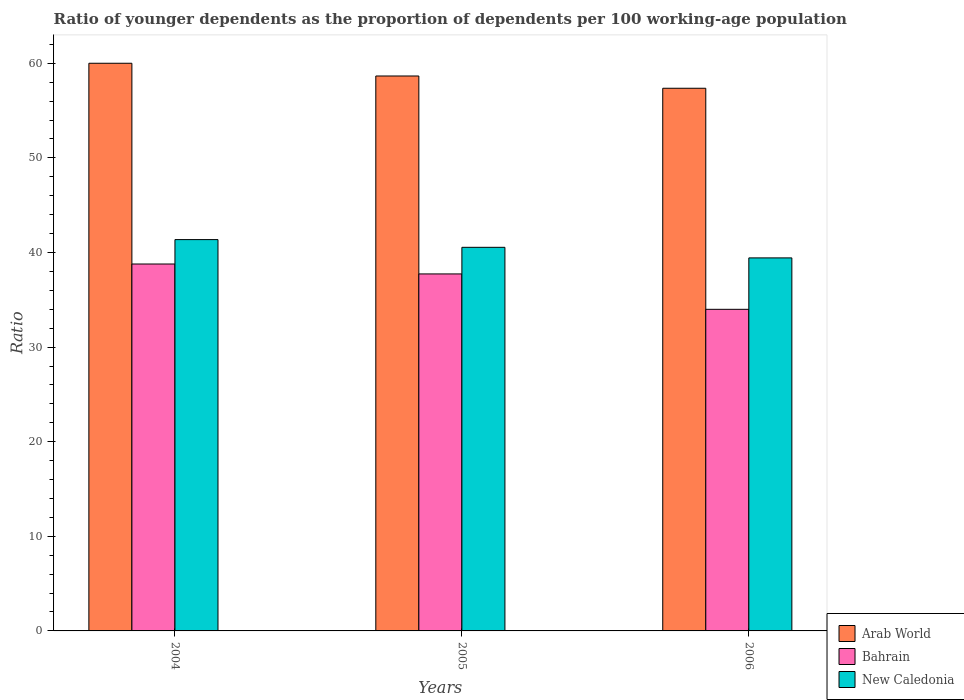How many groups of bars are there?
Offer a terse response. 3. What is the age dependency ratio(young) in New Caledonia in 2005?
Your response must be concise. 40.55. Across all years, what is the maximum age dependency ratio(young) in Arab World?
Your answer should be compact. 60. Across all years, what is the minimum age dependency ratio(young) in Bahrain?
Your answer should be very brief. 33.99. What is the total age dependency ratio(young) in New Caledonia in the graph?
Ensure brevity in your answer.  121.34. What is the difference between the age dependency ratio(young) in New Caledonia in 2004 and that in 2005?
Offer a terse response. 0.82. What is the difference between the age dependency ratio(young) in New Caledonia in 2006 and the age dependency ratio(young) in Bahrain in 2004?
Your response must be concise. 0.65. What is the average age dependency ratio(young) in New Caledonia per year?
Your answer should be very brief. 40.45. In the year 2004, what is the difference between the age dependency ratio(young) in Arab World and age dependency ratio(young) in Bahrain?
Your answer should be very brief. 21.22. What is the ratio of the age dependency ratio(young) in New Caledonia in 2005 to that in 2006?
Your response must be concise. 1.03. Is the age dependency ratio(young) in Bahrain in 2004 less than that in 2006?
Your response must be concise. No. What is the difference between the highest and the second highest age dependency ratio(young) in Bahrain?
Provide a short and direct response. 1.05. What is the difference between the highest and the lowest age dependency ratio(young) in New Caledonia?
Provide a short and direct response. 1.93. In how many years, is the age dependency ratio(young) in Arab World greater than the average age dependency ratio(young) in Arab World taken over all years?
Offer a terse response. 1. Is the sum of the age dependency ratio(young) in New Caledonia in 2004 and 2005 greater than the maximum age dependency ratio(young) in Arab World across all years?
Your answer should be very brief. Yes. What does the 1st bar from the left in 2004 represents?
Give a very brief answer. Arab World. What does the 2nd bar from the right in 2004 represents?
Provide a short and direct response. Bahrain. Is it the case that in every year, the sum of the age dependency ratio(young) in Arab World and age dependency ratio(young) in New Caledonia is greater than the age dependency ratio(young) in Bahrain?
Your response must be concise. Yes. How many bars are there?
Your response must be concise. 9. Are all the bars in the graph horizontal?
Provide a succinct answer. No. Does the graph contain any zero values?
Offer a very short reply. No. How many legend labels are there?
Make the answer very short. 3. What is the title of the graph?
Offer a very short reply. Ratio of younger dependents as the proportion of dependents per 100 working-age population. What is the label or title of the Y-axis?
Your response must be concise. Ratio. What is the Ratio of Arab World in 2004?
Make the answer very short. 60. What is the Ratio of Bahrain in 2004?
Provide a short and direct response. 38.78. What is the Ratio in New Caledonia in 2004?
Offer a very short reply. 41.36. What is the Ratio of Arab World in 2005?
Make the answer very short. 58.66. What is the Ratio in Bahrain in 2005?
Provide a succinct answer. 37.73. What is the Ratio in New Caledonia in 2005?
Your response must be concise. 40.55. What is the Ratio in Arab World in 2006?
Give a very brief answer. 57.36. What is the Ratio of Bahrain in 2006?
Ensure brevity in your answer.  33.99. What is the Ratio in New Caledonia in 2006?
Offer a very short reply. 39.43. Across all years, what is the maximum Ratio in Arab World?
Ensure brevity in your answer.  60. Across all years, what is the maximum Ratio in Bahrain?
Offer a terse response. 38.78. Across all years, what is the maximum Ratio of New Caledonia?
Your response must be concise. 41.36. Across all years, what is the minimum Ratio of Arab World?
Ensure brevity in your answer.  57.36. Across all years, what is the minimum Ratio of Bahrain?
Offer a terse response. 33.99. Across all years, what is the minimum Ratio of New Caledonia?
Provide a short and direct response. 39.43. What is the total Ratio in Arab World in the graph?
Keep it short and to the point. 176.02. What is the total Ratio of Bahrain in the graph?
Your response must be concise. 110.51. What is the total Ratio of New Caledonia in the graph?
Offer a terse response. 121.34. What is the difference between the Ratio of Arab World in 2004 and that in 2005?
Provide a succinct answer. 1.35. What is the difference between the Ratio in Bahrain in 2004 and that in 2005?
Ensure brevity in your answer.  1.05. What is the difference between the Ratio in New Caledonia in 2004 and that in 2005?
Provide a short and direct response. 0.82. What is the difference between the Ratio of Arab World in 2004 and that in 2006?
Provide a succinct answer. 2.64. What is the difference between the Ratio of Bahrain in 2004 and that in 2006?
Keep it short and to the point. 4.79. What is the difference between the Ratio of New Caledonia in 2004 and that in 2006?
Provide a succinct answer. 1.93. What is the difference between the Ratio in Arab World in 2005 and that in 2006?
Offer a very short reply. 1.3. What is the difference between the Ratio of Bahrain in 2005 and that in 2006?
Your answer should be very brief. 3.74. What is the difference between the Ratio in New Caledonia in 2005 and that in 2006?
Give a very brief answer. 1.12. What is the difference between the Ratio of Arab World in 2004 and the Ratio of Bahrain in 2005?
Your answer should be very brief. 22.27. What is the difference between the Ratio in Arab World in 2004 and the Ratio in New Caledonia in 2005?
Provide a short and direct response. 19.46. What is the difference between the Ratio in Bahrain in 2004 and the Ratio in New Caledonia in 2005?
Make the answer very short. -1.76. What is the difference between the Ratio in Arab World in 2004 and the Ratio in Bahrain in 2006?
Offer a very short reply. 26.01. What is the difference between the Ratio in Arab World in 2004 and the Ratio in New Caledonia in 2006?
Make the answer very short. 20.57. What is the difference between the Ratio of Bahrain in 2004 and the Ratio of New Caledonia in 2006?
Your answer should be very brief. -0.65. What is the difference between the Ratio in Arab World in 2005 and the Ratio in Bahrain in 2006?
Offer a terse response. 24.66. What is the difference between the Ratio in Arab World in 2005 and the Ratio in New Caledonia in 2006?
Provide a succinct answer. 19.23. What is the difference between the Ratio in Bahrain in 2005 and the Ratio in New Caledonia in 2006?
Ensure brevity in your answer.  -1.7. What is the average Ratio in Arab World per year?
Provide a succinct answer. 58.67. What is the average Ratio in Bahrain per year?
Keep it short and to the point. 36.84. What is the average Ratio in New Caledonia per year?
Your answer should be compact. 40.45. In the year 2004, what is the difference between the Ratio in Arab World and Ratio in Bahrain?
Keep it short and to the point. 21.22. In the year 2004, what is the difference between the Ratio of Arab World and Ratio of New Caledonia?
Provide a succinct answer. 18.64. In the year 2004, what is the difference between the Ratio of Bahrain and Ratio of New Caledonia?
Offer a very short reply. -2.58. In the year 2005, what is the difference between the Ratio in Arab World and Ratio in Bahrain?
Offer a terse response. 20.92. In the year 2005, what is the difference between the Ratio of Arab World and Ratio of New Caledonia?
Your answer should be very brief. 18.11. In the year 2005, what is the difference between the Ratio of Bahrain and Ratio of New Caledonia?
Your response must be concise. -2.81. In the year 2006, what is the difference between the Ratio of Arab World and Ratio of Bahrain?
Your response must be concise. 23.37. In the year 2006, what is the difference between the Ratio in Arab World and Ratio in New Caledonia?
Ensure brevity in your answer.  17.93. In the year 2006, what is the difference between the Ratio of Bahrain and Ratio of New Caledonia?
Your response must be concise. -5.43. What is the ratio of the Ratio in Bahrain in 2004 to that in 2005?
Provide a succinct answer. 1.03. What is the ratio of the Ratio of New Caledonia in 2004 to that in 2005?
Your answer should be very brief. 1.02. What is the ratio of the Ratio of Arab World in 2004 to that in 2006?
Provide a succinct answer. 1.05. What is the ratio of the Ratio in Bahrain in 2004 to that in 2006?
Give a very brief answer. 1.14. What is the ratio of the Ratio of New Caledonia in 2004 to that in 2006?
Give a very brief answer. 1.05. What is the ratio of the Ratio of Arab World in 2005 to that in 2006?
Make the answer very short. 1.02. What is the ratio of the Ratio of Bahrain in 2005 to that in 2006?
Provide a short and direct response. 1.11. What is the ratio of the Ratio of New Caledonia in 2005 to that in 2006?
Your answer should be very brief. 1.03. What is the difference between the highest and the second highest Ratio in Arab World?
Make the answer very short. 1.35. What is the difference between the highest and the second highest Ratio in Bahrain?
Offer a very short reply. 1.05. What is the difference between the highest and the second highest Ratio of New Caledonia?
Provide a succinct answer. 0.82. What is the difference between the highest and the lowest Ratio of Arab World?
Provide a short and direct response. 2.64. What is the difference between the highest and the lowest Ratio of Bahrain?
Offer a terse response. 4.79. What is the difference between the highest and the lowest Ratio of New Caledonia?
Provide a short and direct response. 1.93. 